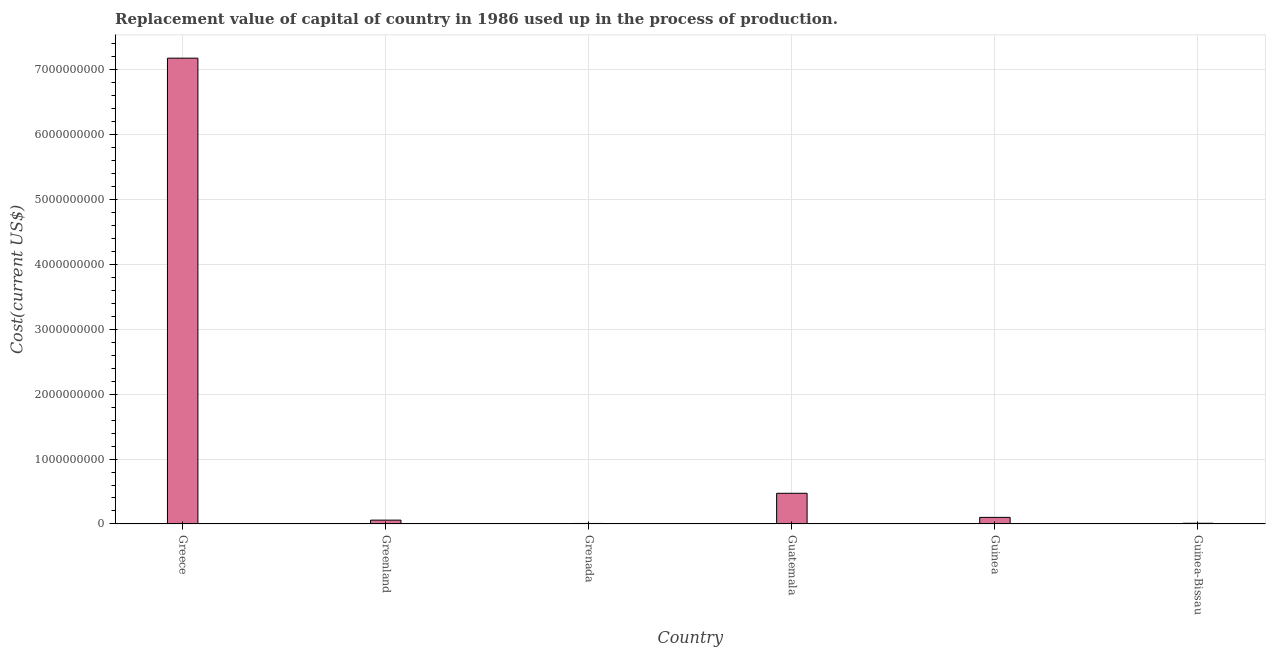Does the graph contain any zero values?
Your answer should be very brief. No. Does the graph contain grids?
Ensure brevity in your answer.  Yes. What is the title of the graph?
Keep it short and to the point. Replacement value of capital of country in 1986 used up in the process of production. What is the label or title of the X-axis?
Ensure brevity in your answer.  Country. What is the label or title of the Y-axis?
Keep it short and to the point. Cost(current US$). What is the consumption of fixed capital in Guatemala?
Give a very brief answer. 4.73e+08. Across all countries, what is the maximum consumption of fixed capital?
Make the answer very short. 7.17e+09. Across all countries, what is the minimum consumption of fixed capital?
Your answer should be very brief. 7.87e+06. In which country was the consumption of fixed capital minimum?
Give a very brief answer. Grenada. What is the sum of the consumption of fixed capital?
Give a very brief answer. 7.82e+09. What is the difference between the consumption of fixed capital in Guatemala and Guinea?
Offer a very short reply. 3.71e+08. What is the average consumption of fixed capital per country?
Give a very brief answer. 1.30e+09. What is the median consumption of fixed capital?
Ensure brevity in your answer.  8.03e+07. What is the ratio of the consumption of fixed capital in Grenada to that in Guatemala?
Ensure brevity in your answer.  0.02. Is the consumption of fixed capital in Greenland less than that in Guinea-Bissau?
Your response must be concise. No. What is the difference between the highest and the second highest consumption of fixed capital?
Your response must be concise. 6.70e+09. Is the sum of the consumption of fixed capital in Greece and Guinea-Bissau greater than the maximum consumption of fixed capital across all countries?
Provide a succinct answer. Yes. What is the difference between the highest and the lowest consumption of fixed capital?
Offer a very short reply. 7.16e+09. How many bars are there?
Keep it short and to the point. 6. What is the difference between two consecutive major ticks on the Y-axis?
Your answer should be compact. 1.00e+09. What is the Cost(current US$) in Greece?
Provide a short and direct response. 7.17e+09. What is the Cost(current US$) in Greenland?
Ensure brevity in your answer.  5.92e+07. What is the Cost(current US$) in Grenada?
Your answer should be very brief. 7.87e+06. What is the Cost(current US$) in Guatemala?
Ensure brevity in your answer.  4.73e+08. What is the Cost(current US$) in Guinea?
Provide a succinct answer. 1.01e+08. What is the Cost(current US$) in Guinea-Bissau?
Provide a short and direct response. 1.11e+07. What is the difference between the Cost(current US$) in Greece and Greenland?
Ensure brevity in your answer.  7.11e+09. What is the difference between the Cost(current US$) in Greece and Grenada?
Your answer should be compact. 7.16e+09. What is the difference between the Cost(current US$) in Greece and Guatemala?
Ensure brevity in your answer.  6.70e+09. What is the difference between the Cost(current US$) in Greece and Guinea?
Make the answer very short. 7.07e+09. What is the difference between the Cost(current US$) in Greece and Guinea-Bissau?
Offer a terse response. 7.16e+09. What is the difference between the Cost(current US$) in Greenland and Grenada?
Your answer should be very brief. 5.13e+07. What is the difference between the Cost(current US$) in Greenland and Guatemala?
Your answer should be very brief. -4.13e+08. What is the difference between the Cost(current US$) in Greenland and Guinea?
Ensure brevity in your answer.  -4.23e+07. What is the difference between the Cost(current US$) in Greenland and Guinea-Bissau?
Keep it short and to the point. 4.80e+07. What is the difference between the Cost(current US$) in Grenada and Guatemala?
Provide a short and direct response. -4.65e+08. What is the difference between the Cost(current US$) in Grenada and Guinea?
Your response must be concise. -9.36e+07. What is the difference between the Cost(current US$) in Grenada and Guinea-Bissau?
Your response must be concise. -3.26e+06. What is the difference between the Cost(current US$) in Guatemala and Guinea?
Keep it short and to the point. 3.71e+08. What is the difference between the Cost(current US$) in Guatemala and Guinea-Bissau?
Offer a very short reply. 4.61e+08. What is the difference between the Cost(current US$) in Guinea and Guinea-Bissau?
Your answer should be compact. 9.03e+07. What is the ratio of the Cost(current US$) in Greece to that in Greenland?
Make the answer very short. 121.18. What is the ratio of the Cost(current US$) in Greece to that in Grenada?
Give a very brief answer. 910.8. What is the ratio of the Cost(current US$) in Greece to that in Guatemala?
Your answer should be compact. 15.18. What is the ratio of the Cost(current US$) in Greece to that in Guinea?
Provide a succinct answer. 70.68. What is the ratio of the Cost(current US$) in Greece to that in Guinea-Bissau?
Provide a short and direct response. 644.27. What is the ratio of the Cost(current US$) in Greenland to that in Grenada?
Your response must be concise. 7.52. What is the ratio of the Cost(current US$) in Greenland to that in Guinea?
Make the answer very short. 0.58. What is the ratio of the Cost(current US$) in Greenland to that in Guinea-Bissau?
Provide a succinct answer. 5.32. What is the ratio of the Cost(current US$) in Grenada to that in Guatemala?
Offer a very short reply. 0.02. What is the ratio of the Cost(current US$) in Grenada to that in Guinea?
Provide a succinct answer. 0.08. What is the ratio of the Cost(current US$) in Grenada to that in Guinea-Bissau?
Provide a succinct answer. 0.71. What is the ratio of the Cost(current US$) in Guatemala to that in Guinea?
Your response must be concise. 4.66. What is the ratio of the Cost(current US$) in Guatemala to that in Guinea-Bissau?
Your answer should be compact. 42.45. What is the ratio of the Cost(current US$) in Guinea to that in Guinea-Bissau?
Offer a very short reply. 9.12. 